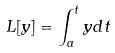<formula> <loc_0><loc_0><loc_500><loc_500>L [ y ] = \int _ { a } ^ { t } y d t</formula> 